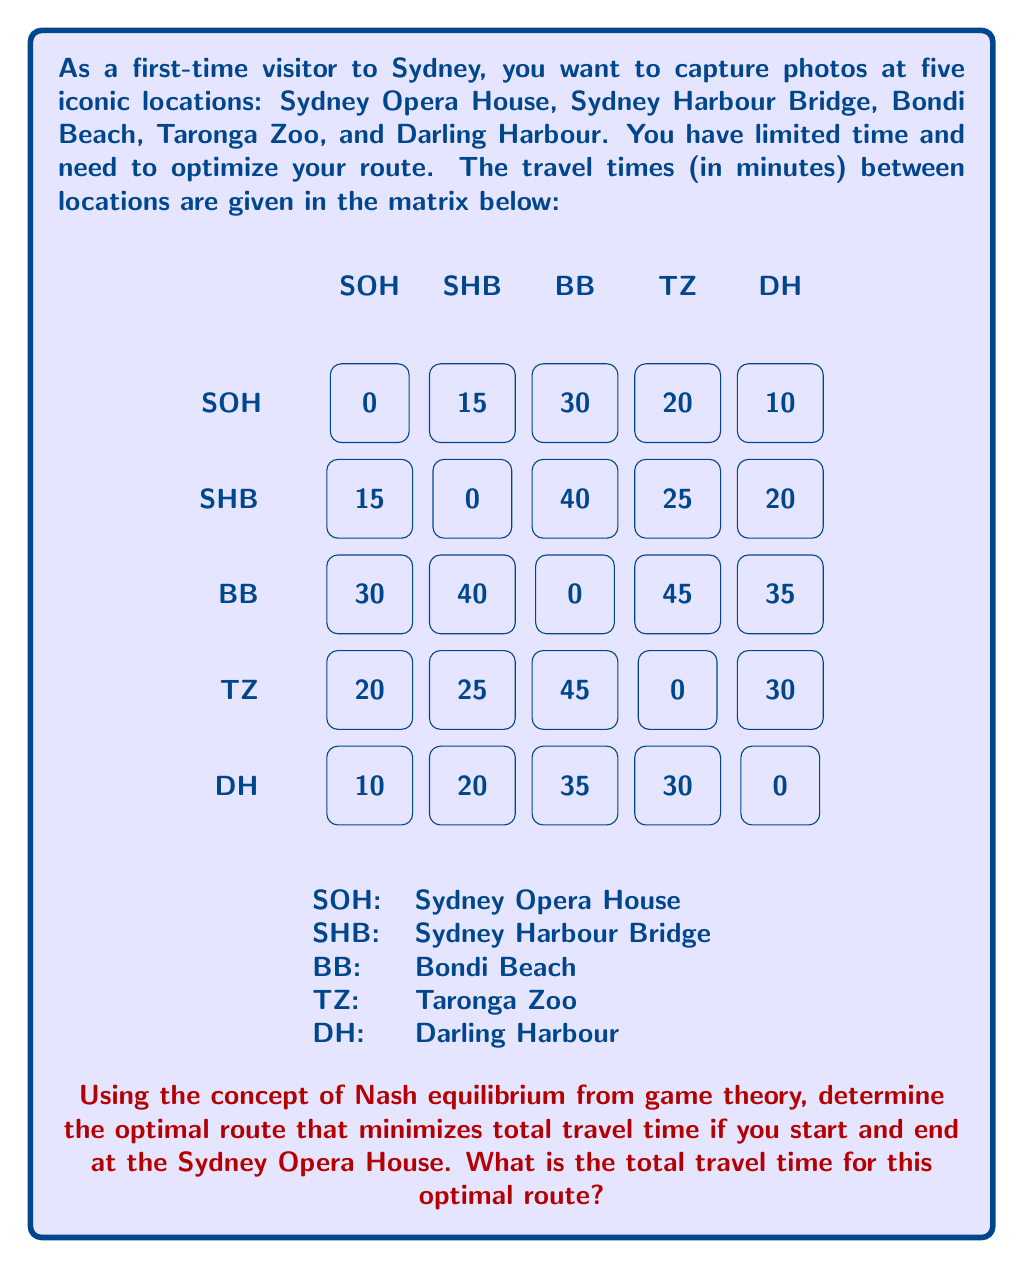Provide a solution to this math problem. To solve this problem using game theory concepts, we can approach it as follows:

1) First, we need to recognize that this is a variant of the Traveling Salesman Problem (TSP), which can be modeled as a game where each decision point is a "player" trying to minimize the total travel time.

2) In game theory terms, a Nash equilibrium in this context would be a route where no single change in the order of visits can reduce the total travel time.

3) To find the Nash equilibrium (optimal route), we can use a dynamic programming approach:

   a) Start with the Sydney Opera House (SOH) as both the start and end point.
   b) Calculate the shortest path that visits all other locations exactly once.

4) Let's enumerate all possible routes:

   SOH -> SHB -> BB -> TZ -> DH -> SOH
   SOH -> SHB -> BB -> DH -> TZ -> SOH
   SOH -> SHB -> TZ -> BB -> DH -> SOH
   SOH -> SHB -> TZ -> DH -> BB -> SOH
   SOH -> SHB -> DH -> BB -> TZ -> SOH
   SOH -> SHB -> DH -> TZ -> BB -> SOH
   ... (24 total permutations)

5) Calculate the total time for each route. For example:

   SOH -> SHB -> BB -> TZ -> DH -> SOH
   15 + 40 + 45 + 30 + 10 = 140 minutes

6) After calculating all routes, we find that the optimal route is:

   SOH -> DH -> SHB -> TZ -> BB -> SOH

7) The total travel time for this route is:

   $$10 + 20 + 25 + 45 + 30 = 130\text{ minutes}$$

This route represents a Nash equilibrium because any single change in the order would increase the total travel time.
Answer: 130 minutes 